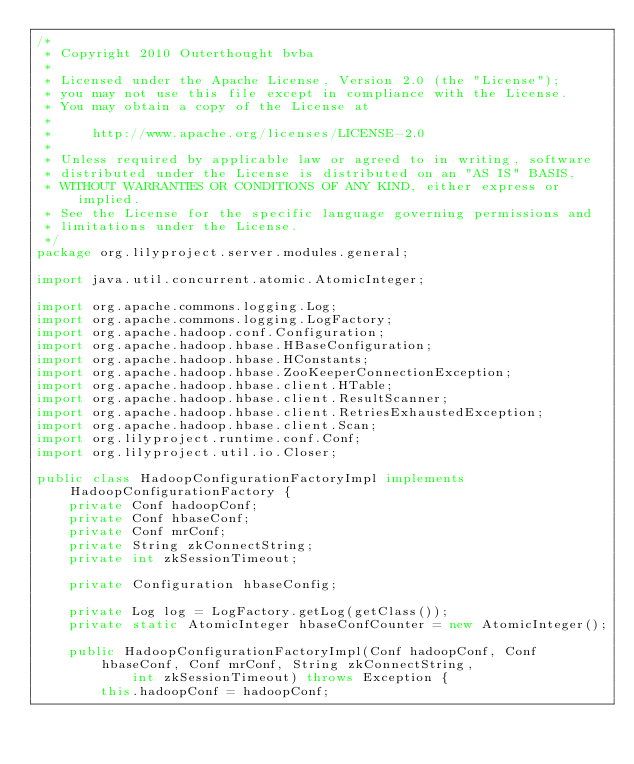<code> <loc_0><loc_0><loc_500><loc_500><_Java_>/*
 * Copyright 2010 Outerthought bvba
 *
 * Licensed under the Apache License, Version 2.0 (the "License");
 * you may not use this file except in compliance with the License.
 * You may obtain a copy of the License at
 *
 *     http://www.apache.org/licenses/LICENSE-2.0
 *
 * Unless required by applicable law or agreed to in writing, software
 * distributed under the License is distributed on an "AS IS" BASIS,
 * WITHOUT WARRANTIES OR CONDITIONS OF ANY KIND, either express or implied.
 * See the License for the specific language governing permissions and
 * limitations under the License.
 */
package org.lilyproject.server.modules.general;

import java.util.concurrent.atomic.AtomicInteger;

import org.apache.commons.logging.Log;
import org.apache.commons.logging.LogFactory;
import org.apache.hadoop.conf.Configuration;
import org.apache.hadoop.hbase.HBaseConfiguration;
import org.apache.hadoop.hbase.HConstants;
import org.apache.hadoop.hbase.ZooKeeperConnectionException;
import org.apache.hadoop.hbase.client.HTable;
import org.apache.hadoop.hbase.client.ResultScanner;
import org.apache.hadoop.hbase.client.RetriesExhaustedException;
import org.apache.hadoop.hbase.client.Scan;
import org.lilyproject.runtime.conf.Conf;
import org.lilyproject.util.io.Closer;

public class HadoopConfigurationFactoryImpl implements HadoopConfigurationFactory {
    private Conf hadoopConf;
    private Conf hbaseConf;
    private Conf mrConf;
    private String zkConnectString;
    private int zkSessionTimeout;

    private Configuration hbaseConfig;

    private Log log = LogFactory.getLog(getClass());
    private static AtomicInteger hbaseConfCounter = new AtomicInteger();

    public HadoopConfigurationFactoryImpl(Conf hadoopConf, Conf hbaseConf, Conf mrConf, String zkConnectString,
            int zkSessionTimeout) throws Exception {
        this.hadoopConf = hadoopConf;</code> 